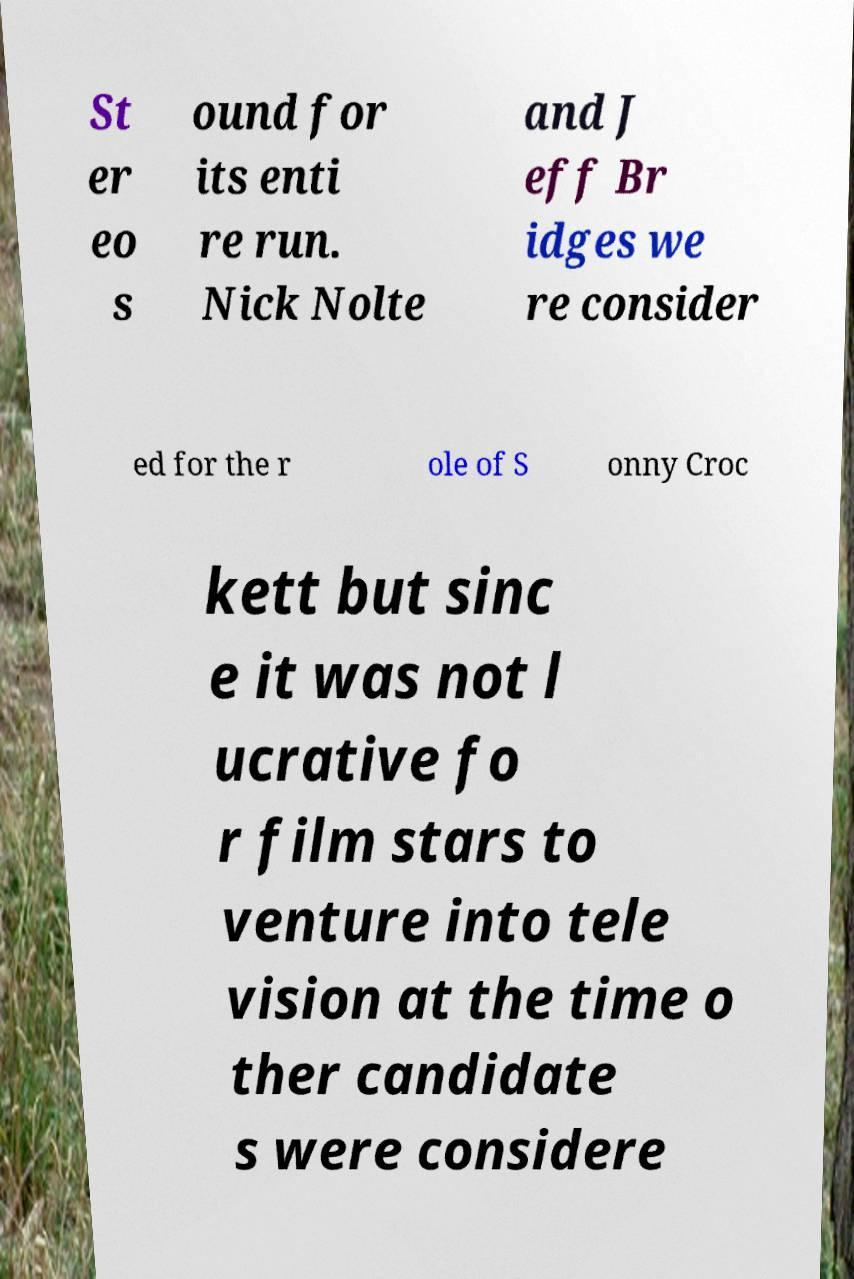For documentation purposes, I need the text within this image transcribed. Could you provide that? St er eo s ound for its enti re run. Nick Nolte and J eff Br idges we re consider ed for the r ole of S onny Croc kett but sinc e it was not l ucrative fo r film stars to venture into tele vision at the time o ther candidate s were considere 